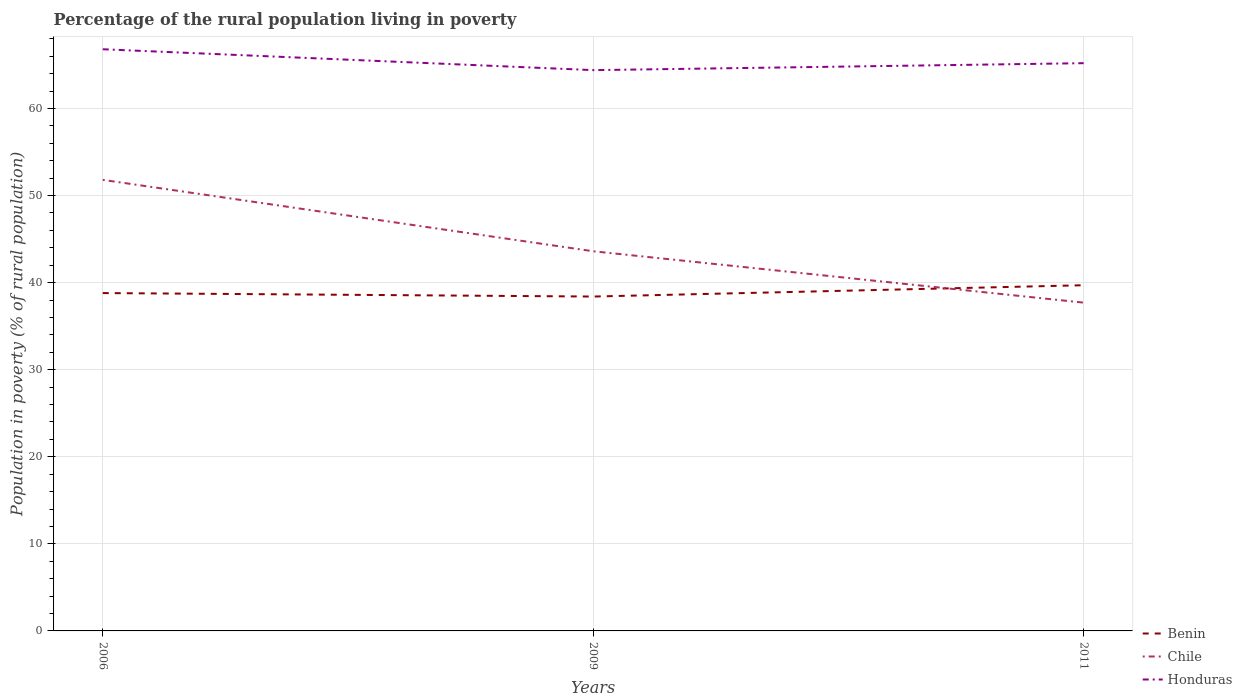How many different coloured lines are there?
Offer a terse response. 3. Does the line corresponding to Benin intersect with the line corresponding to Chile?
Make the answer very short. Yes. Is the number of lines equal to the number of legend labels?
Ensure brevity in your answer.  Yes. Across all years, what is the maximum percentage of the rural population living in poverty in Benin?
Offer a terse response. 38.4. What is the total percentage of the rural population living in poverty in Benin in the graph?
Make the answer very short. 0.4. What is the difference between the highest and the second highest percentage of the rural population living in poverty in Honduras?
Provide a succinct answer. 2.4. How many lines are there?
Your answer should be compact. 3. How many years are there in the graph?
Provide a short and direct response. 3. Does the graph contain any zero values?
Give a very brief answer. No. Does the graph contain grids?
Offer a terse response. Yes. Where does the legend appear in the graph?
Offer a very short reply. Bottom right. What is the title of the graph?
Your answer should be very brief. Percentage of the rural population living in poverty. What is the label or title of the X-axis?
Give a very brief answer. Years. What is the label or title of the Y-axis?
Make the answer very short. Population in poverty (% of rural population). What is the Population in poverty (% of rural population) in Benin in 2006?
Give a very brief answer. 38.8. What is the Population in poverty (% of rural population) in Chile in 2006?
Your answer should be compact. 51.8. What is the Population in poverty (% of rural population) of Honduras in 2006?
Your answer should be very brief. 66.8. What is the Population in poverty (% of rural population) in Benin in 2009?
Offer a terse response. 38.4. What is the Population in poverty (% of rural population) in Chile in 2009?
Your response must be concise. 43.6. What is the Population in poverty (% of rural population) of Honduras in 2009?
Make the answer very short. 64.4. What is the Population in poverty (% of rural population) in Benin in 2011?
Give a very brief answer. 39.7. What is the Population in poverty (% of rural population) of Chile in 2011?
Keep it short and to the point. 37.7. What is the Population in poverty (% of rural population) in Honduras in 2011?
Your answer should be compact. 65.2. Across all years, what is the maximum Population in poverty (% of rural population) in Benin?
Keep it short and to the point. 39.7. Across all years, what is the maximum Population in poverty (% of rural population) in Chile?
Provide a short and direct response. 51.8. Across all years, what is the maximum Population in poverty (% of rural population) of Honduras?
Give a very brief answer. 66.8. Across all years, what is the minimum Population in poverty (% of rural population) in Benin?
Offer a very short reply. 38.4. Across all years, what is the minimum Population in poverty (% of rural population) in Chile?
Your response must be concise. 37.7. Across all years, what is the minimum Population in poverty (% of rural population) of Honduras?
Offer a terse response. 64.4. What is the total Population in poverty (% of rural population) in Benin in the graph?
Your response must be concise. 116.9. What is the total Population in poverty (% of rural population) in Chile in the graph?
Your answer should be very brief. 133.1. What is the total Population in poverty (% of rural population) of Honduras in the graph?
Your answer should be very brief. 196.4. What is the difference between the Population in poverty (% of rural population) of Benin in 2006 and that in 2009?
Offer a terse response. 0.4. What is the difference between the Population in poverty (% of rural population) of Chile in 2006 and that in 2009?
Keep it short and to the point. 8.2. What is the difference between the Population in poverty (% of rural population) of Honduras in 2006 and that in 2009?
Your answer should be very brief. 2.4. What is the difference between the Population in poverty (% of rural population) of Benin in 2006 and that in 2011?
Ensure brevity in your answer.  -0.9. What is the difference between the Population in poverty (% of rural population) of Chile in 2006 and that in 2011?
Give a very brief answer. 14.1. What is the difference between the Population in poverty (% of rural population) of Benin in 2009 and that in 2011?
Give a very brief answer. -1.3. What is the difference between the Population in poverty (% of rural population) in Honduras in 2009 and that in 2011?
Provide a succinct answer. -0.8. What is the difference between the Population in poverty (% of rural population) in Benin in 2006 and the Population in poverty (% of rural population) in Chile in 2009?
Provide a short and direct response. -4.8. What is the difference between the Population in poverty (% of rural population) of Benin in 2006 and the Population in poverty (% of rural population) of Honduras in 2009?
Give a very brief answer. -25.6. What is the difference between the Population in poverty (% of rural population) in Chile in 2006 and the Population in poverty (% of rural population) in Honduras in 2009?
Ensure brevity in your answer.  -12.6. What is the difference between the Population in poverty (% of rural population) of Benin in 2006 and the Population in poverty (% of rural population) of Chile in 2011?
Offer a very short reply. 1.1. What is the difference between the Population in poverty (% of rural population) in Benin in 2006 and the Population in poverty (% of rural population) in Honduras in 2011?
Offer a very short reply. -26.4. What is the difference between the Population in poverty (% of rural population) of Chile in 2006 and the Population in poverty (% of rural population) of Honduras in 2011?
Your answer should be compact. -13.4. What is the difference between the Population in poverty (% of rural population) in Benin in 2009 and the Population in poverty (% of rural population) in Chile in 2011?
Your answer should be compact. 0.7. What is the difference between the Population in poverty (% of rural population) of Benin in 2009 and the Population in poverty (% of rural population) of Honduras in 2011?
Offer a very short reply. -26.8. What is the difference between the Population in poverty (% of rural population) in Chile in 2009 and the Population in poverty (% of rural population) in Honduras in 2011?
Make the answer very short. -21.6. What is the average Population in poverty (% of rural population) in Benin per year?
Offer a very short reply. 38.97. What is the average Population in poverty (% of rural population) of Chile per year?
Ensure brevity in your answer.  44.37. What is the average Population in poverty (% of rural population) in Honduras per year?
Provide a short and direct response. 65.47. In the year 2006, what is the difference between the Population in poverty (% of rural population) in Benin and Population in poverty (% of rural population) in Chile?
Provide a short and direct response. -13. In the year 2009, what is the difference between the Population in poverty (% of rural population) of Benin and Population in poverty (% of rural population) of Chile?
Give a very brief answer. -5.2. In the year 2009, what is the difference between the Population in poverty (% of rural population) of Chile and Population in poverty (% of rural population) of Honduras?
Keep it short and to the point. -20.8. In the year 2011, what is the difference between the Population in poverty (% of rural population) in Benin and Population in poverty (% of rural population) in Honduras?
Your answer should be very brief. -25.5. In the year 2011, what is the difference between the Population in poverty (% of rural population) in Chile and Population in poverty (% of rural population) in Honduras?
Offer a very short reply. -27.5. What is the ratio of the Population in poverty (% of rural population) in Benin in 2006 to that in 2009?
Make the answer very short. 1.01. What is the ratio of the Population in poverty (% of rural population) of Chile in 2006 to that in 2009?
Give a very brief answer. 1.19. What is the ratio of the Population in poverty (% of rural population) in Honduras in 2006 to that in 2009?
Offer a terse response. 1.04. What is the ratio of the Population in poverty (% of rural population) in Benin in 2006 to that in 2011?
Keep it short and to the point. 0.98. What is the ratio of the Population in poverty (% of rural population) of Chile in 2006 to that in 2011?
Ensure brevity in your answer.  1.37. What is the ratio of the Population in poverty (% of rural population) in Honduras in 2006 to that in 2011?
Your response must be concise. 1.02. What is the ratio of the Population in poverty (% of rural population) of Benin in 2009 to that in 2011?
Provide a short and direct response. 0.97. What is the ratio of the Population in poverty (% of rural population) of Chile in 2009 to that in 2011?
Keep it short and to the point. 1.16. What is the ratio of the Population in poverty (% of rural population) in Honduras in 2009 to that in 2011?
Ensure brevity in your answer.  0.99. What is the difference between the highest and the second highest Population in poverty (% of rural population) in Benin?
Your answer should be very brief. 0.9. What is the difference between the highest and the second highest Population in poverty (% of rural population) in Honduras?
Provide a short and direct response. 1.6. What is the difference between the highest and the lowest Population in poverty (% of rural population) in Chile?
Provide a short and direct response. 14.1. 